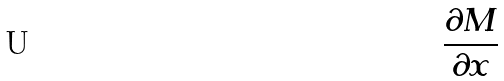<formula> <loc_0><loc_0><loc_500><loc_500>\frac { \partial M } { \partial x }</formula> 